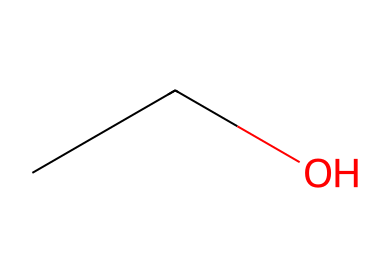What is the chemical name of this compound? The SMILES representation "CCO" corresponds to ethanol, which is commonly known as ethyl alcohol. This is a simple two-carbon alcohol with the hydroxyl (-OH) functional group.
Answer: ethanol How many carbon atoms are in this molecule? The SMILES "CCO" shows there are two "C" atoms in the representation, indicating the molecule contains two carbon atoms.
Answer: two How many hydrogen atoms are present in ethanol? From the structure "CCO", each carbon typically bonds with enough hydrogen atoms to fulfill its tetravalency. With two carbons and one hydroxyl group, ethanol has a total of six hydrogen atoms (C2H6O).
Answer: six What type of chemical bond is present between carbon and hydrogen in ethanol? The bonds between carbon and hydrogen in ethanol are single covalent bonds, as indicated by the absence of any double bonds in the chemical structure. Each carbon atom is bonded to hydrogen via a single bond.
Answer: single Is ethanol classified as a polar or non-polar solvent? The presence of the hydroxyl (-OH) group in ethanol contributes to its polar nature, while the hydrocarbon part makes it somewhat non-polar. Overall, due to the OH group, it is classified primarily as a polar solvent.
Answer: polar What effect does ethanol have on the central nervous system? Ethanol is a depressant, which means it slows down the functions of the central nervous system, leading to decreased inhibition, slowed reaction times, and impaired judgment, especially at higher concentrations typically consumed at events like music festivals.
Answer: depressant How many functional groups are present in ethanol's structure? Ethanol contains one functional group, which is the hydroxyl (-OH) group. This is the defining feature of alcohols and influences the chemical properties of ethanol.
Answer: one 